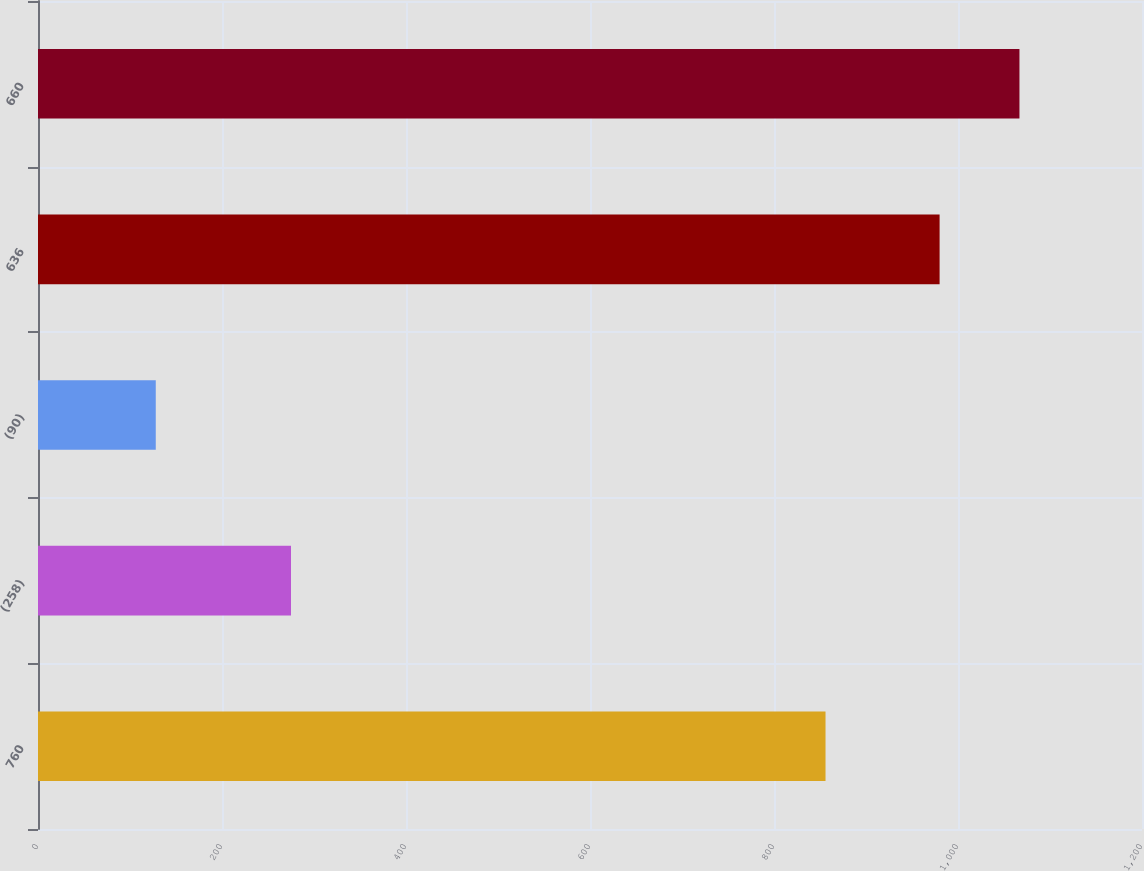Convert chart. <chart><loc_0><loc_0><loc_500><loc_500><bar_chart><fcel>760<fcel>(258)<fcel>(90)<fcel>636<fcel>660<nl><fcel>856<fcel>275<fcel>128<fcel>980<fcel>1066.8<nl></chart> 